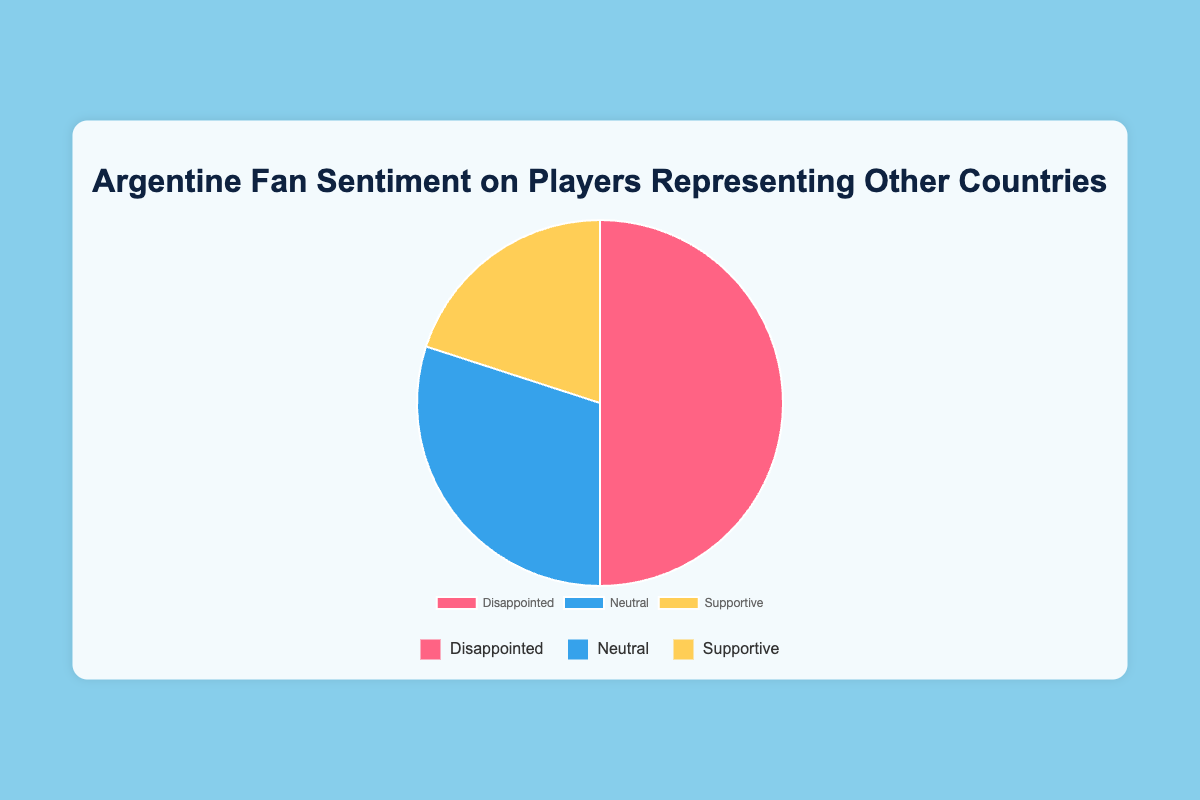Which sentiment has the highest percentage? The "Disappointed" sentiment has the highest percentage at 50%, as indicated by the largest slice in the pie chart.
Answer: Disappointed What is the proportion of fans that are either supportive or neutral combined? To find the combined proportion, add the percentages of "Supportive" and "Neutral". Supportive is 20% and Neutral is 30%. So, 20% + 30% = 50%.
Answer: 50% How much larger is the "Disappointed" segment compared to the "Supportive" segment? Subtract the percentage of "Supportive" (20%) from "Disappointed" (50%). 50% - 20% = 30%.
Answer: 30% Which sentiment has roughly one-third of the total fan sentiment? The "Neutral" sentiment is 30%, which is roughly one-third of the total sentiment distribution.
Answer: Neutral What color represents the "Supportive" sentiment in the pie chart? The "Supportive" sentiment is represented by the color yellow in the pie chart.
Answer: Yellow By how many percentage points does the "Disappointed" sentiment exceed the "Neutral" sentiment? Subtract the "Neutral" percentage (30%) from the "Disappointed" percentage (50%). 50% - 30% = 20%.
Answer: 20% What percentage of fans are neither disappointed nor supportive? Add the percentages of "Neutral" (30%) and "Supportive" (20%), and subtract from 100%. 100% - (30% + 20%) = 50%.
Answer: 50% Which sentiment group is represented by the color red in the chart? The "Disappointed" sentiment is represented by the color red in the chart.
Answer: Disappointed Compare the combined percentage of "Supportive" and "Neutral" with "Disappointed". Which is greater and by how much? The combined percentage of "Supportive" and "Neutral" is 50% (20% + 30%), which is equal to "Disappointed" at 50%. Therefore, they are equal.
Answer: Equal What is the difference in percentage points between the largest and smallest sentiment groups? The largest group is "Disappointed" at 50% and the smallest is "Supportive" at 20%. The difference is 50% - 20% = 30%.
Answer: 30% 